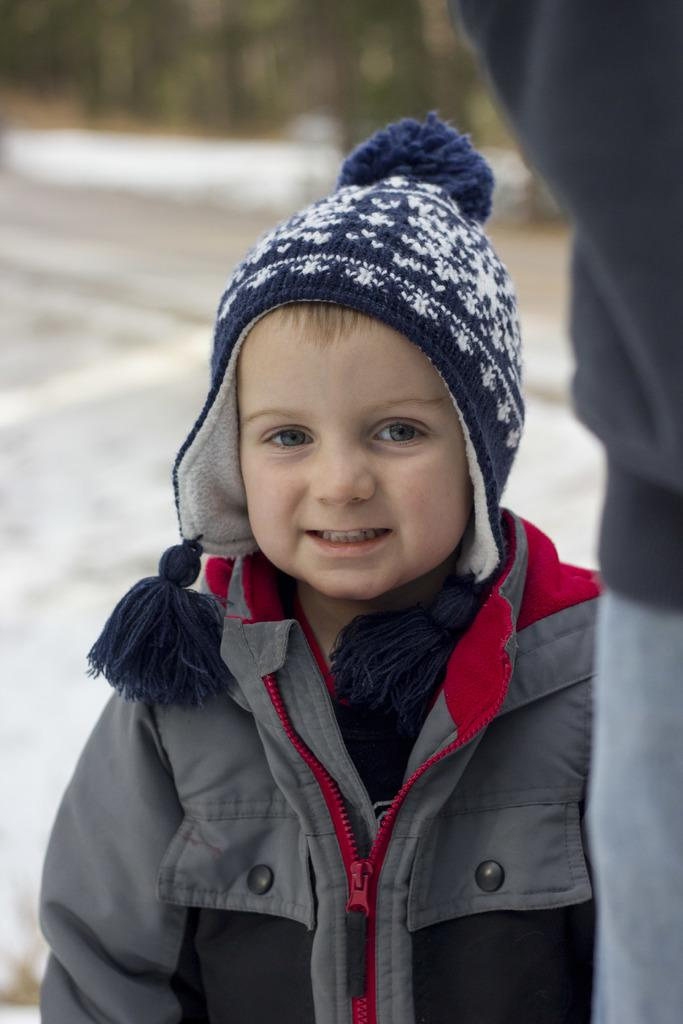What is the main subject in the foreground of the image? There is a boy in the foreground of the image. What is the boy wearing on his head? The boy is wearing a woolen cap. Can you describe anything on the right side of the image? There may be a person on the right side of the image. What can be seen in the background of the image? There is a road visible in the background of the image. What type of flower is being baked in the oven in the image? There is no flower or oven present in the image. What statement is the boy making in the image? The image does not show the boy making any statement, so it cannot be determined from the image. 